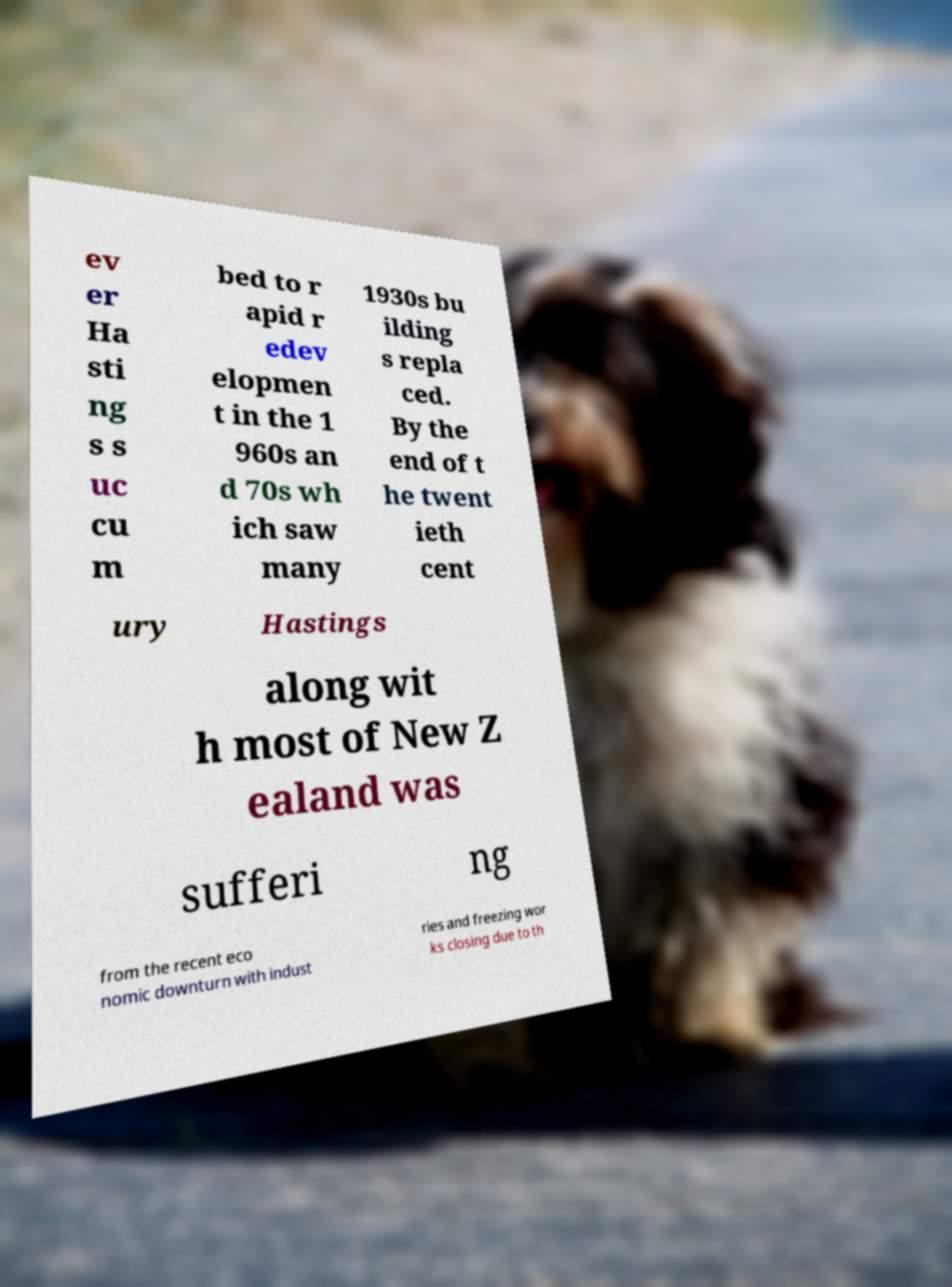For documentation purposes, I need the text within this image transcribed. Could you provide that? ev er Ha sti ng s s uc cu m bed to r apid r edev elopmen t in the 1 960s an d 70s wh ich saw many 1930s bu ilding s repla ced. By the end of t he twent ieth cent ury Hastings along wit h most of New Z ealand was sufferi ng from the recent eco nomic downturn with indust ries and freezing wor ks closing due to th 